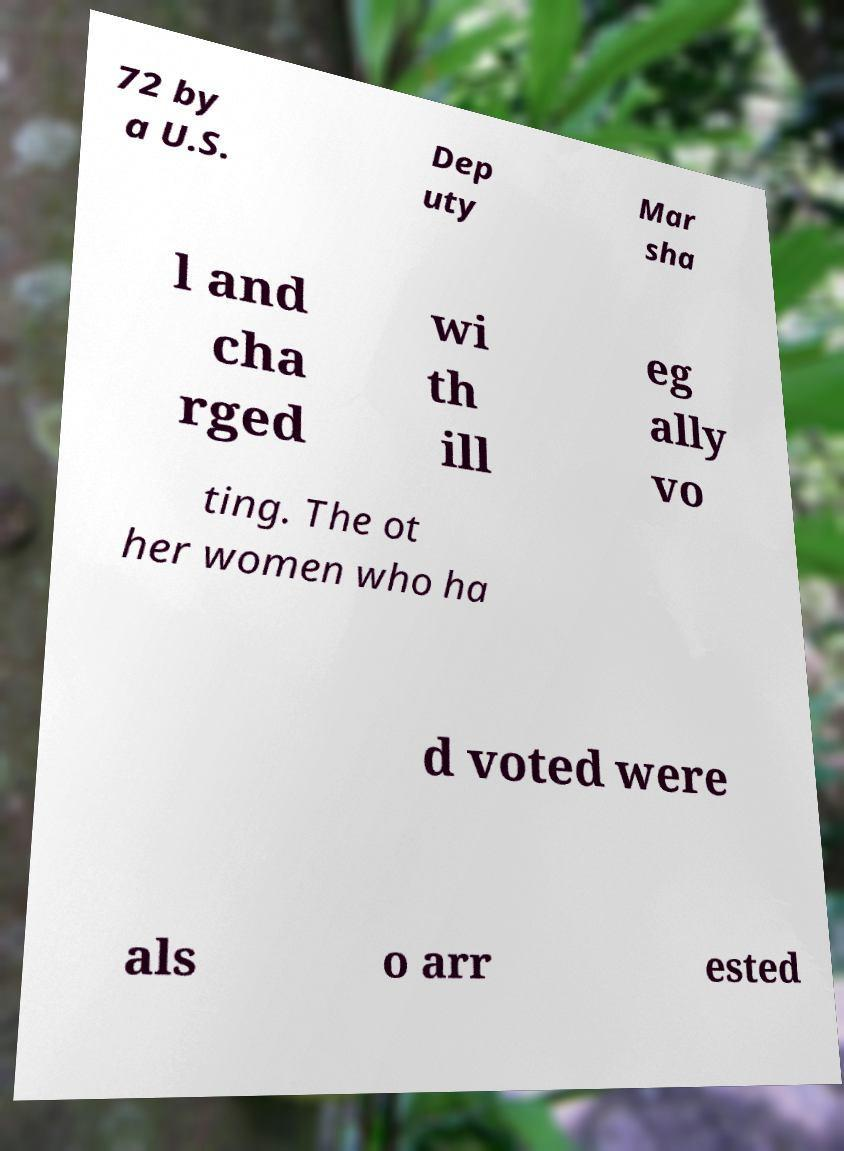Can you read and provide the text displayed in the image?This photo seems to have some interesting text. Can you extract and type it out for me? 72 by a U.S. Dep uty Mar sha l and cha rged wi th ill eg ally vo ting. The ot her women who ha d voted were als o arr ested 